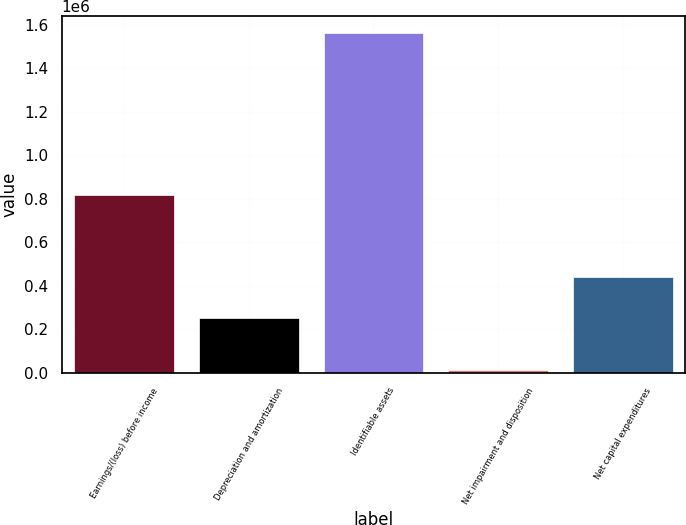Convert chart to OTSL. <chart><loc_0><loc_0><loc_500><loc_500><bar_chart><fcel>Earnings/(loss) before income<fcel>Depreciation and amortization<fcel>Identifiable assets<fcel>Net impairment and disposition<fcel>Net capital expenditures<nl><fcel>817815<fcel>250339<fcel>1.56297e+06<fcel>13647<fcel>440228<nl></chart> 